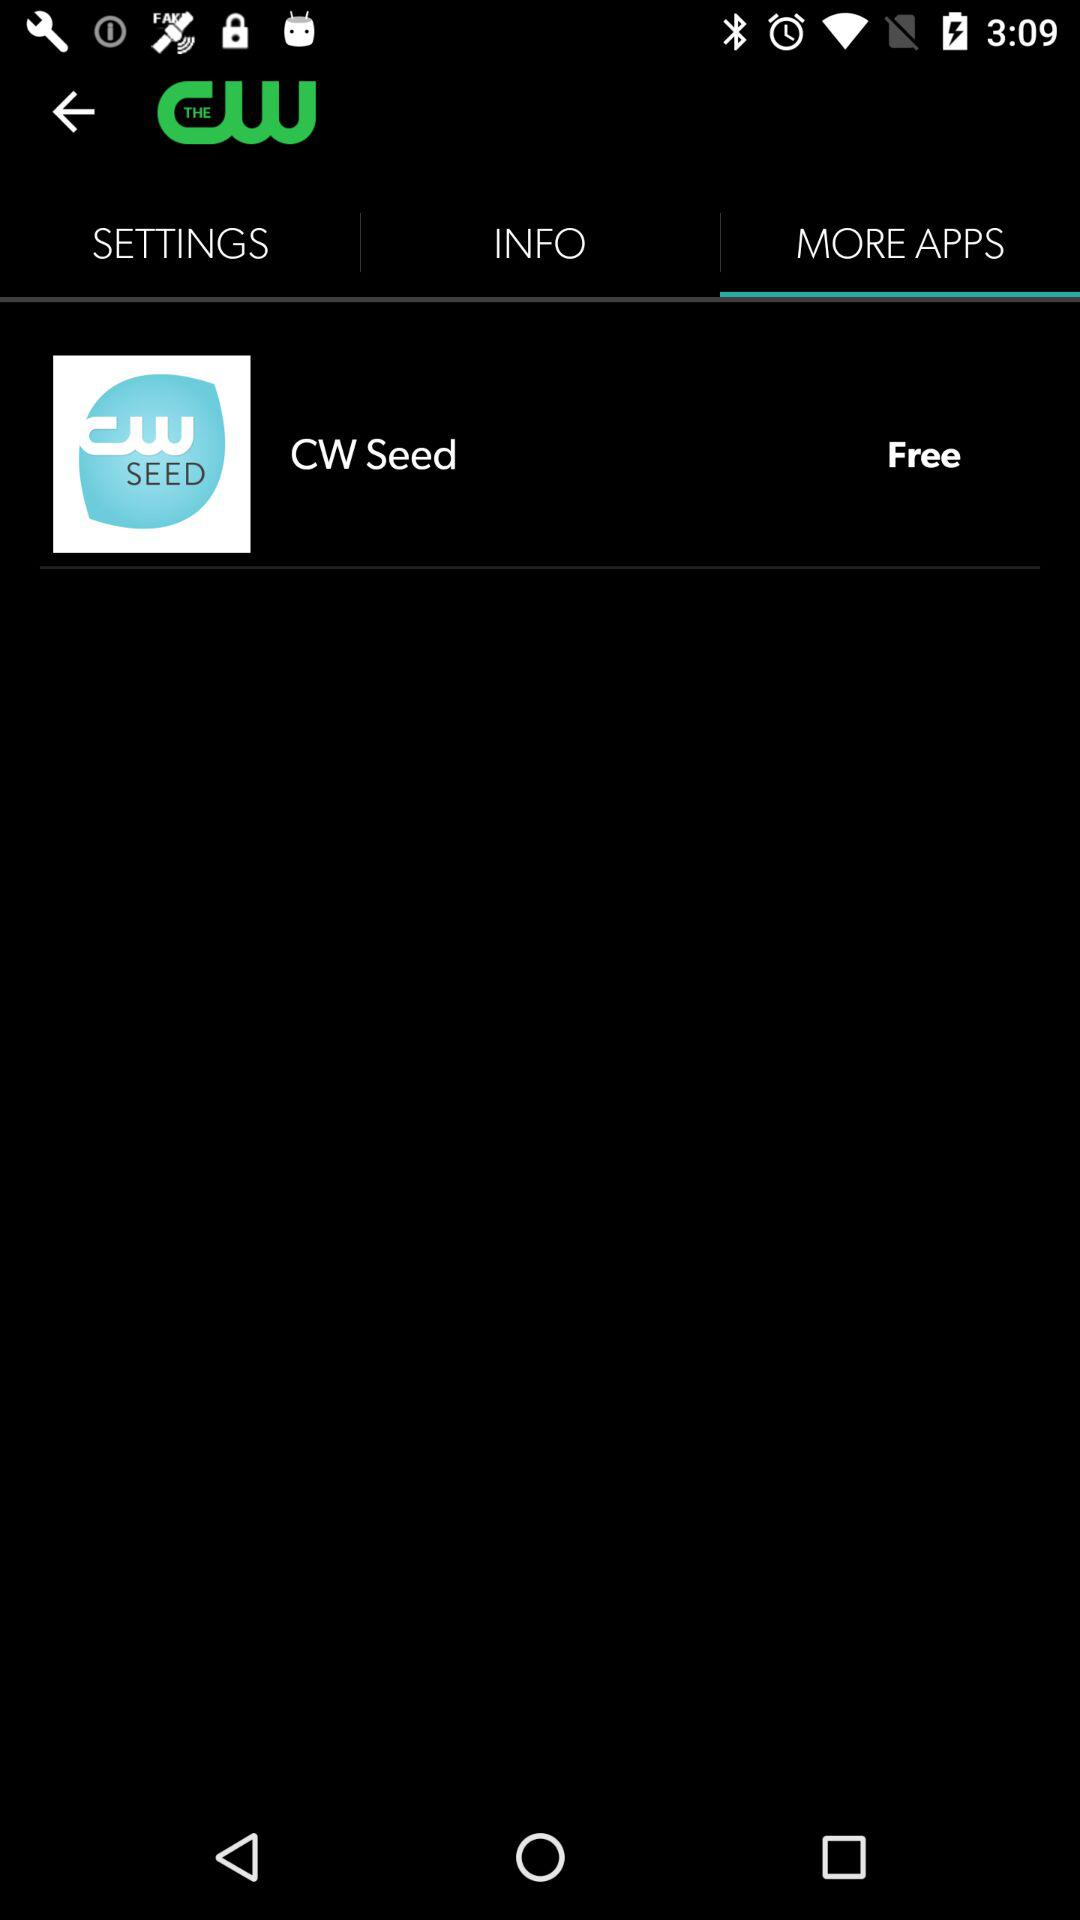How much do we have to pay to use the CW Seed app? The CW Seed app is free. 